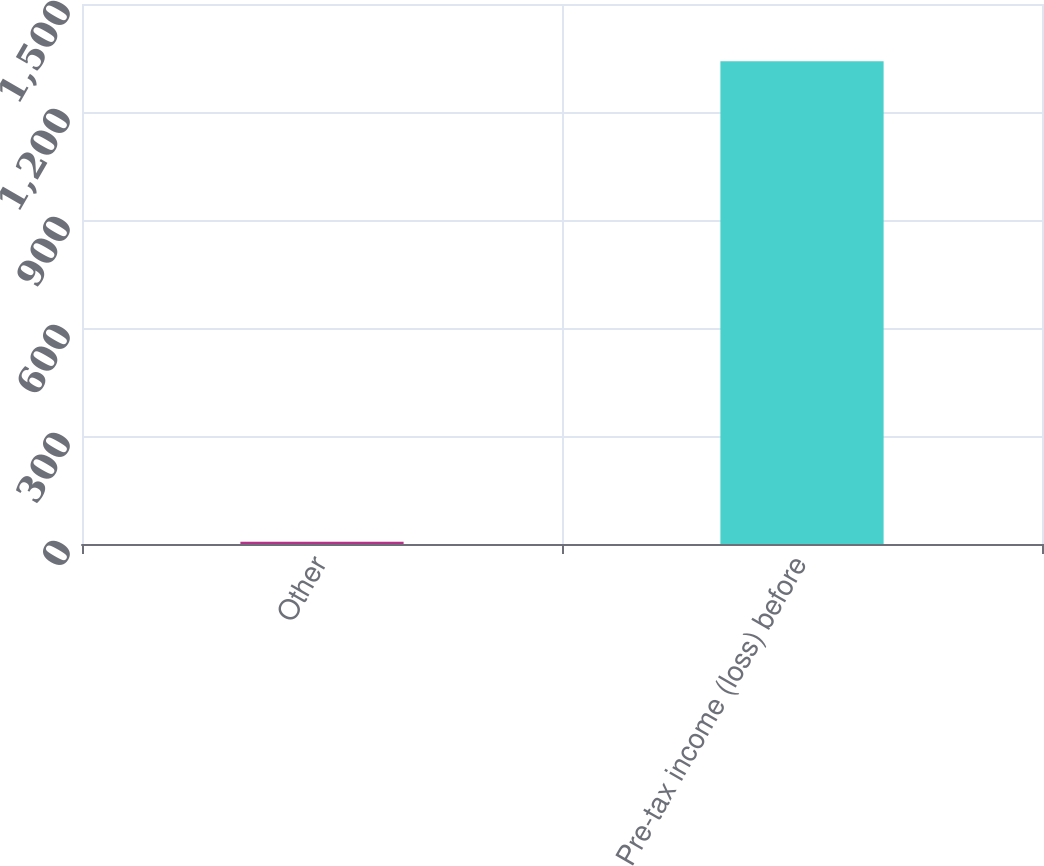Convert chart to OTSL. <chart><loc_0><loc_0><loc_500><loc_500><bar_chart><fcel>Other<fcel>Pre-tax income (loss) before<nl><fcel>6<fcel>1341<nl></chart> 